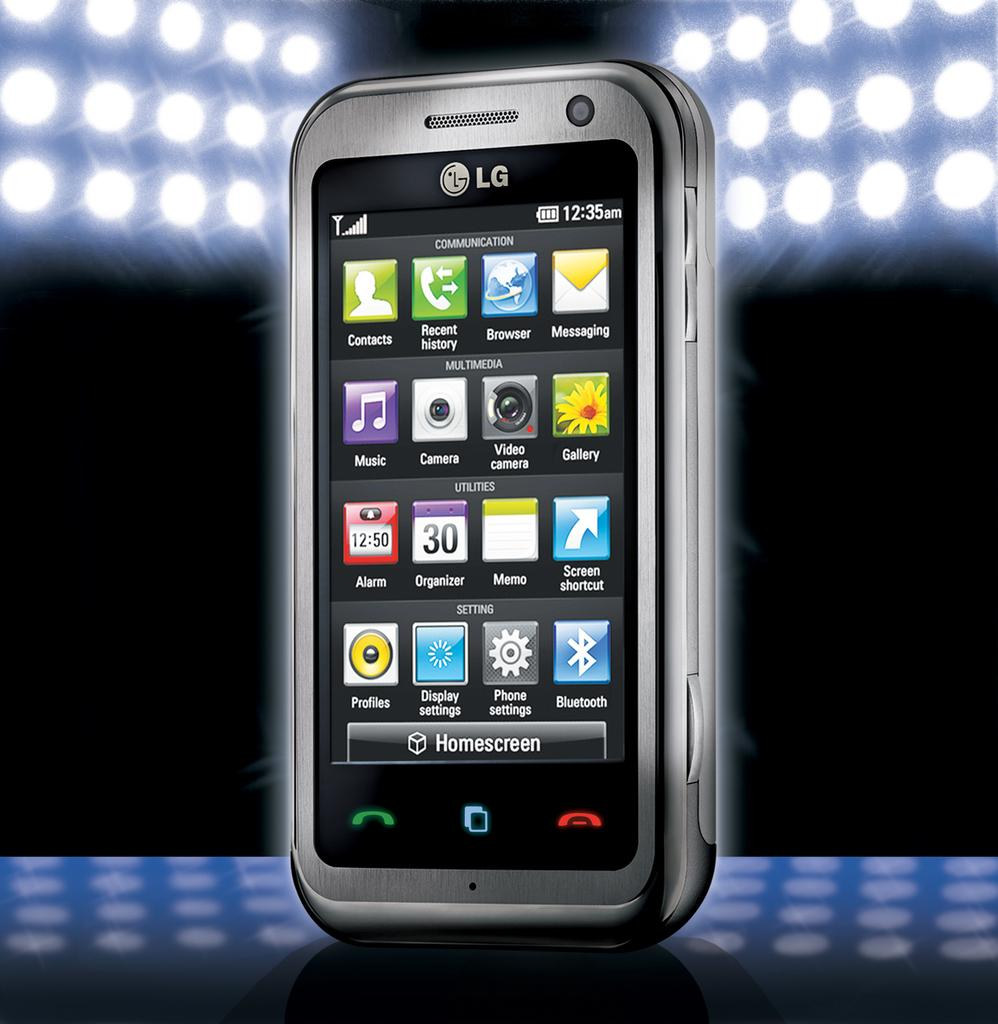<image>
Give a short and clear explanation of the subsequent image. The LG phone is on display showing the home screen. 